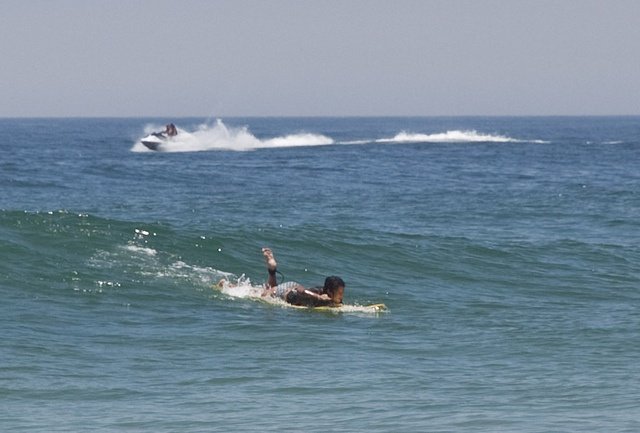Describe the objects in this image and their specific colors. I can see people in darkgray, black, gray, and lightgray tones, surfboard in darkgray, lightgray, and gray tones, boat in darkgray, lightgray, and gray tones, people in darkgray and gray tones, and people in darkgray and gray tones in this image. 